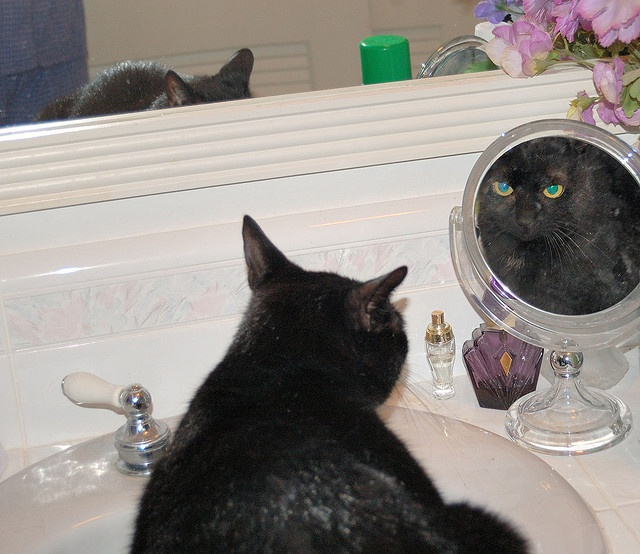Describe the objects in this image and their specific colors. I can see cat in gray, black, and darkgray tones, sink in gray, darkgray, lightgray, and black tones, cat in gray and black tones, potted plant in gray, darkgray, violet, and lightpink tones, and cat in gray and black tones in this image. 